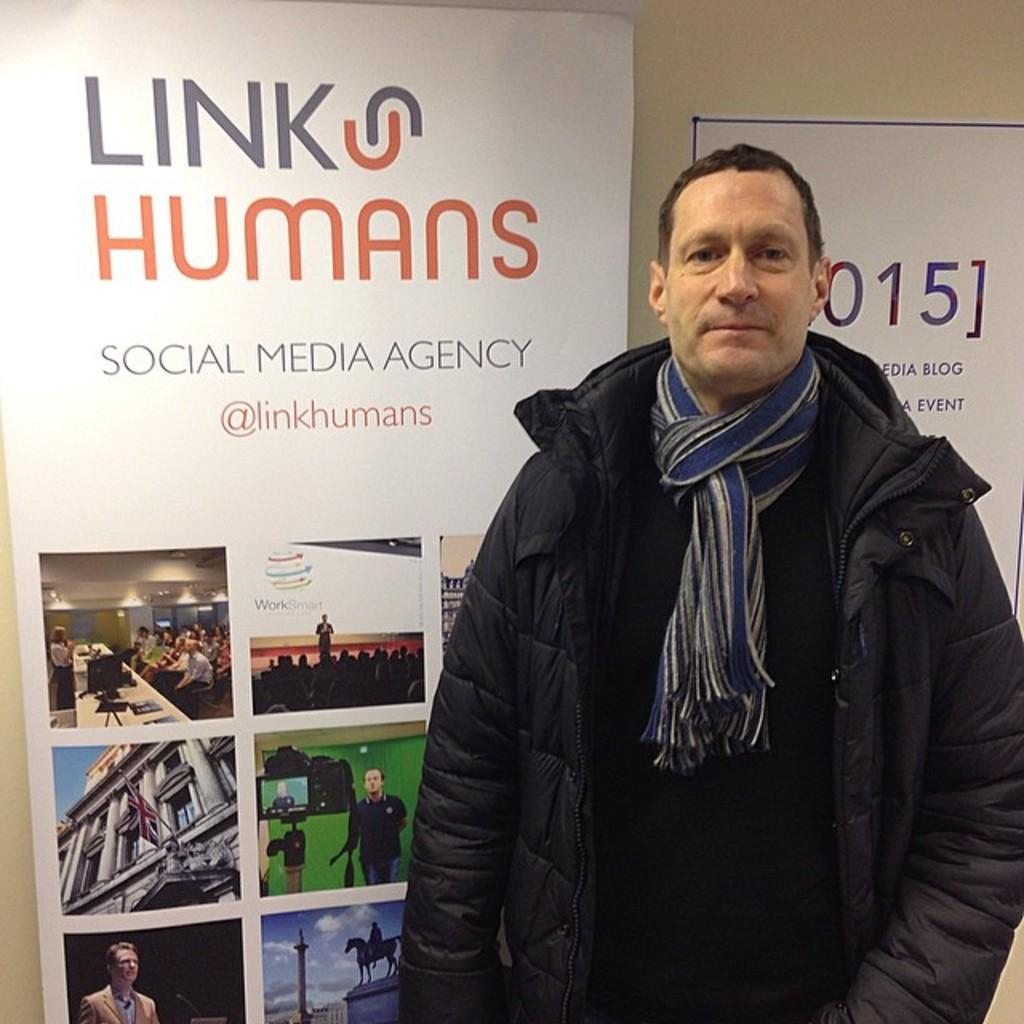What is the main subject in the foreground of the image? There is a man standing in the foreground of the image. What can be seen in the background of the image? There are two posters visible in the background of the image. What type of pollution is depicted in the image? There is no depiction of pollution in the image; it features a man standing in the foreground and two posters in the background. 